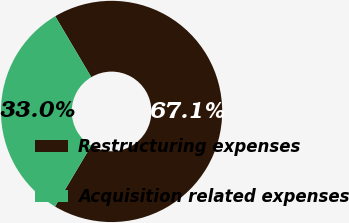<chart> <loc_0><loc_0><loc_500><loc_500><pie_chart><fcel>Restructuring expenses<fcel>Acquisition related expenses<nl><fcel>67.05%<fcel>32.95%<nl></chart> 